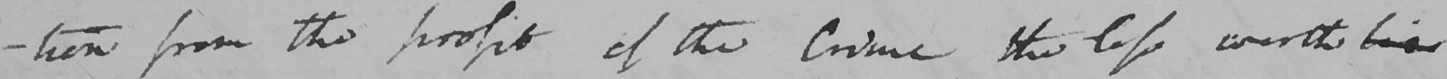Can you read and transcribe this handwriting? -tion from the profit of the crime the less worth his 